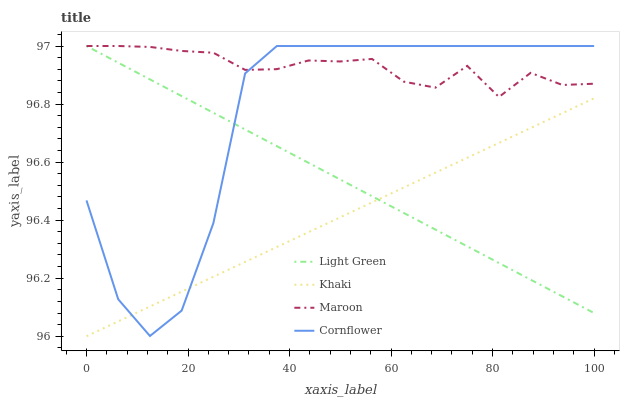Does Khaki have the minimum area under the curve?
Answer yes or no. Yes. Does Maroon have the maximum area under the curve?
Answer yes or no. Yes. Does Maroon have the minimum area under the curve?
Answer yes or no. No. Does Khaki have the maximum area under the curve?
Answer yes or no. No. Is Khaki the smoothest?
Answer yes or no. Yes. Is Cornflower the roughest?
Answer yes or no. Yes. Is Maroon the smoothest?
Answer yes or no. No. Is Maroon the roughest?
Answer yes or no. No. Does Khaki have the lowest value?
Answer yes or no. Yes. Does Maroon have the lowest value?
Answer yes or no. No. Does Light Green have the highest value?
Answer yes or no. Yes. Does Khaki have the highest value?
Answer yes or no. No. Is Khaki less than Maroon?
Answer yes or no. Yes. Is Maroon greater than Khaki?
Answer yes or no. Yes. Does Khaki intersect Light Green?
Answer yes or no. Yes. Is Khaki less than Light Green?
Answer yes or no. No. Is Khaki greater than Light Green?
Answer yes or no. No. Does Khaki intersect Maroon?
Answer yes or no. No. 